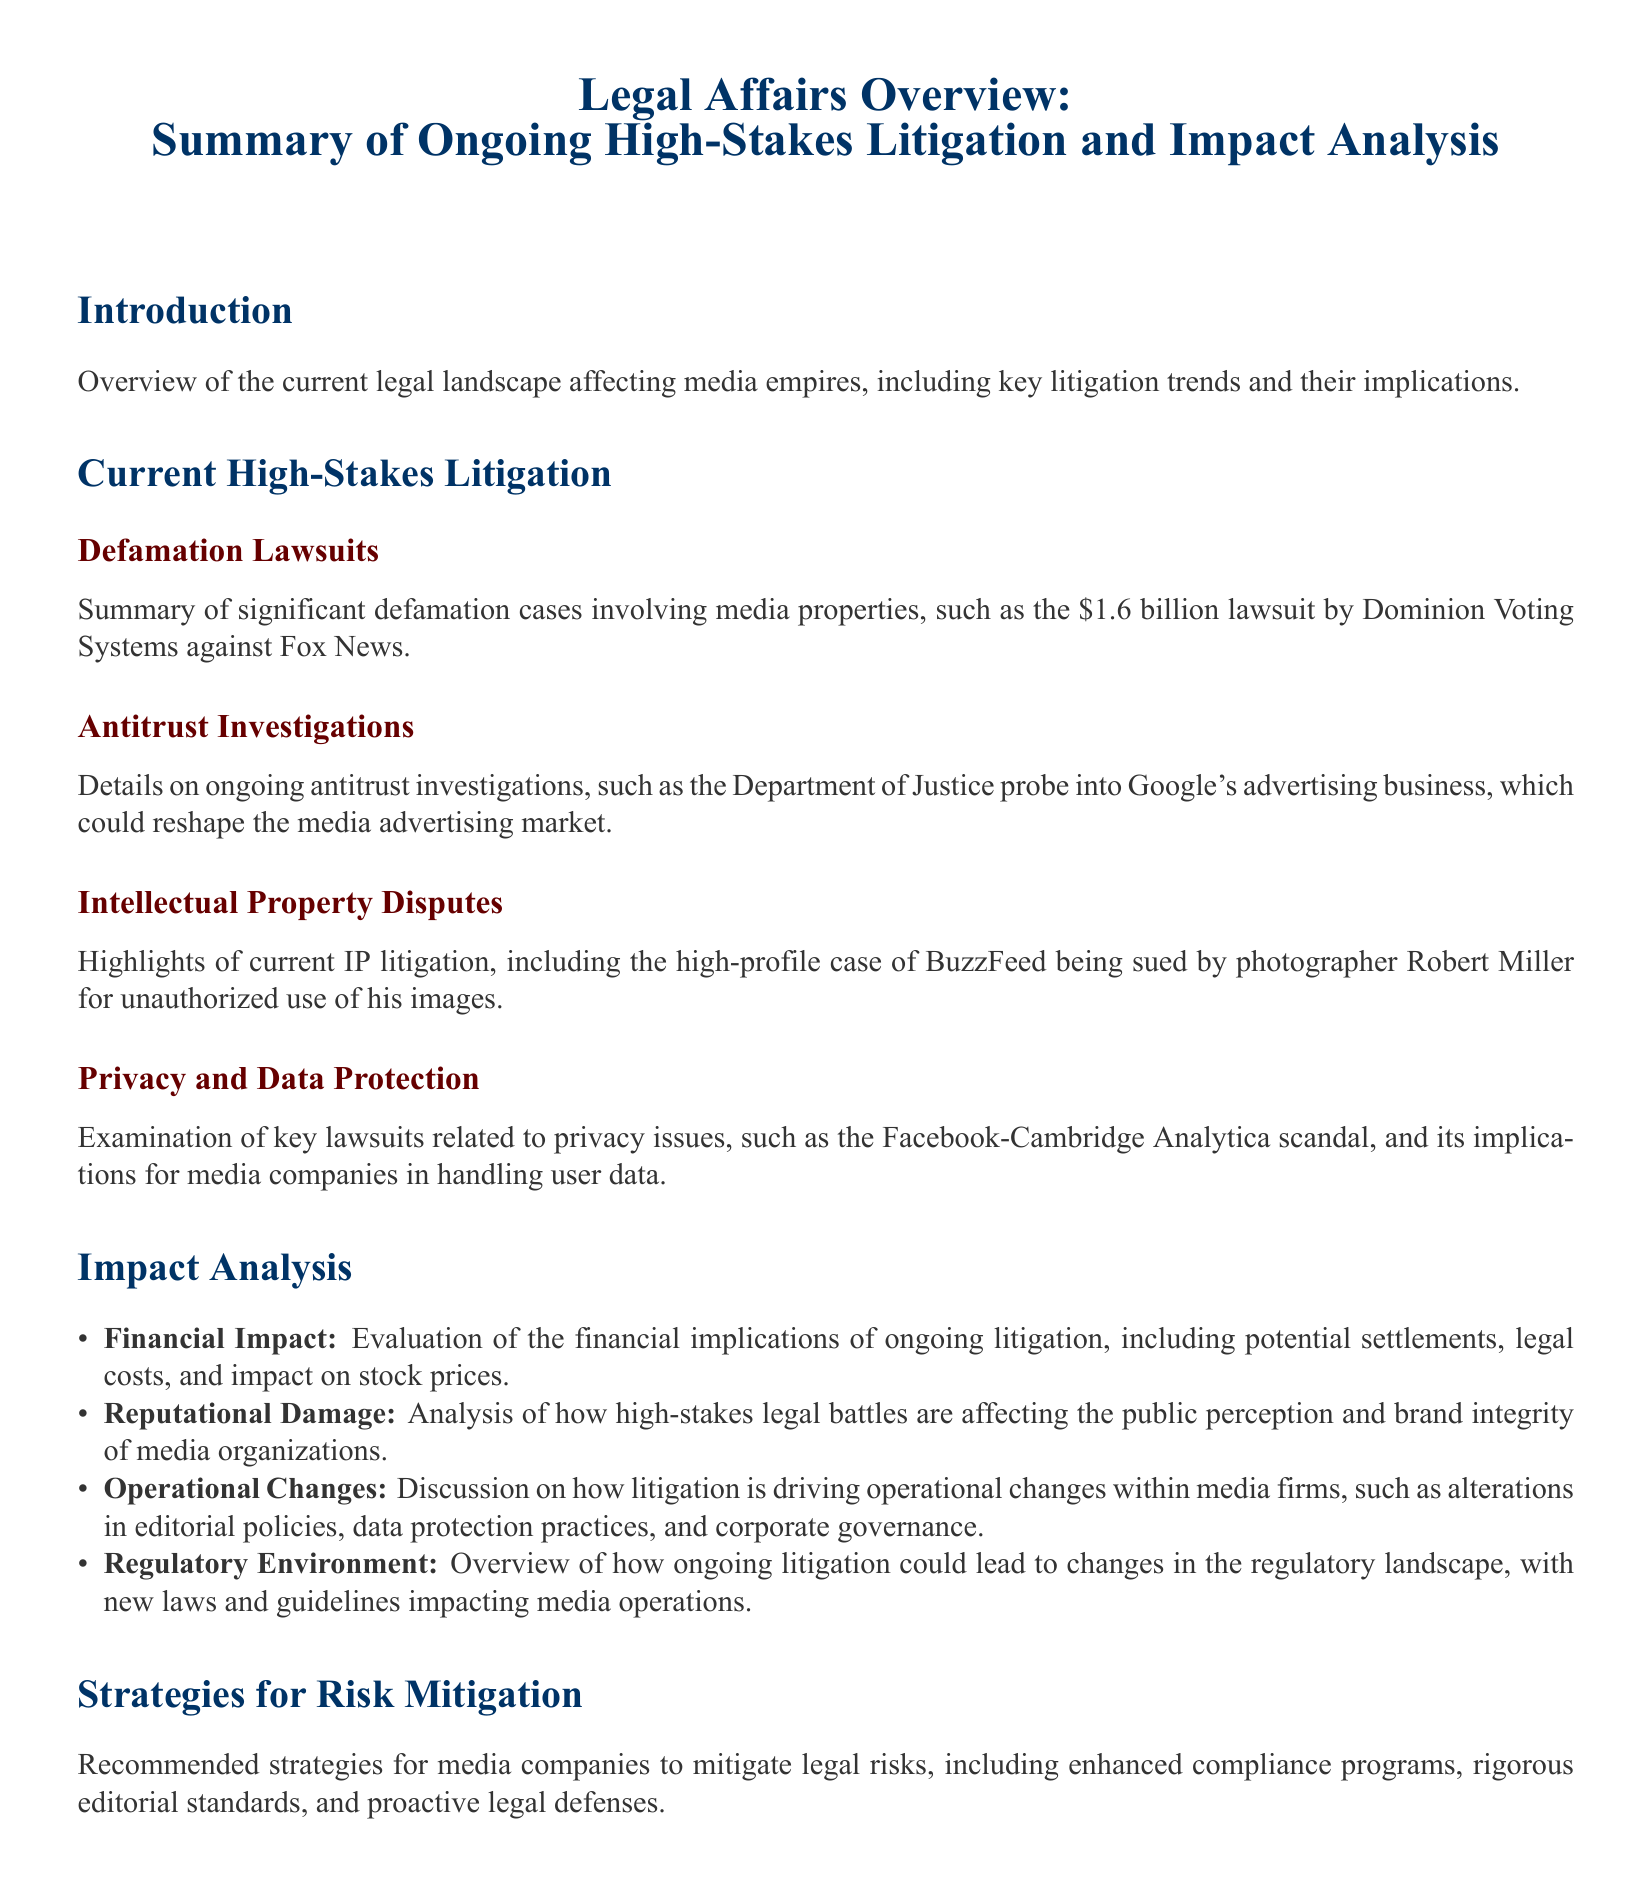What is the title of the document? The title clearly states the subject matter of the syllabus, which outlines its focus on legal affairs and ongoing litigation.
Answer: Legal Affairs Overview: Summary of Ongoing High-Stakes Litigation and Impact Analysis What is the amount of the lawsuit by Dominion Voting Systems? The document provides specific figures associated with significant legal cases, including this high-profile defamation lawsuit.
Answer: $1.6 billion Which company is under investigation by the Department of Justice? The document references ongoing probes into specific companies impacting the media landscape, like Google's advertising business.
Answer: Google What type of lawsuit involves BuzzFeed and Robert Miller? The document summarizes various legal challenges faced by media entities, highlighting specific cases and their nature.
Answer: Intellectual Property Dispute What key scandal is associated with Facebook in the context of privacy? The document notes significant cases related to privacy issues, providing specific examples to illustrate these challenges.
Answer: Cambridge Analytica What is one of the financial impacts discussed in the document? The impact analysis section delves into different repercussions of litigation on media organizations, specifying particular financial aspects.
Answer: Legal costs How do high-stakes legal battles affect media organizations? The document discusses the broader implications of ongoing litigation on public perception and brand integrity.
Answer: Reputational Damage What are recommended strategies for media companies? The document provides insight into practical recommendations for organizations to minimize legal exposure and risks.
Answer: Enhanced compliance programs 